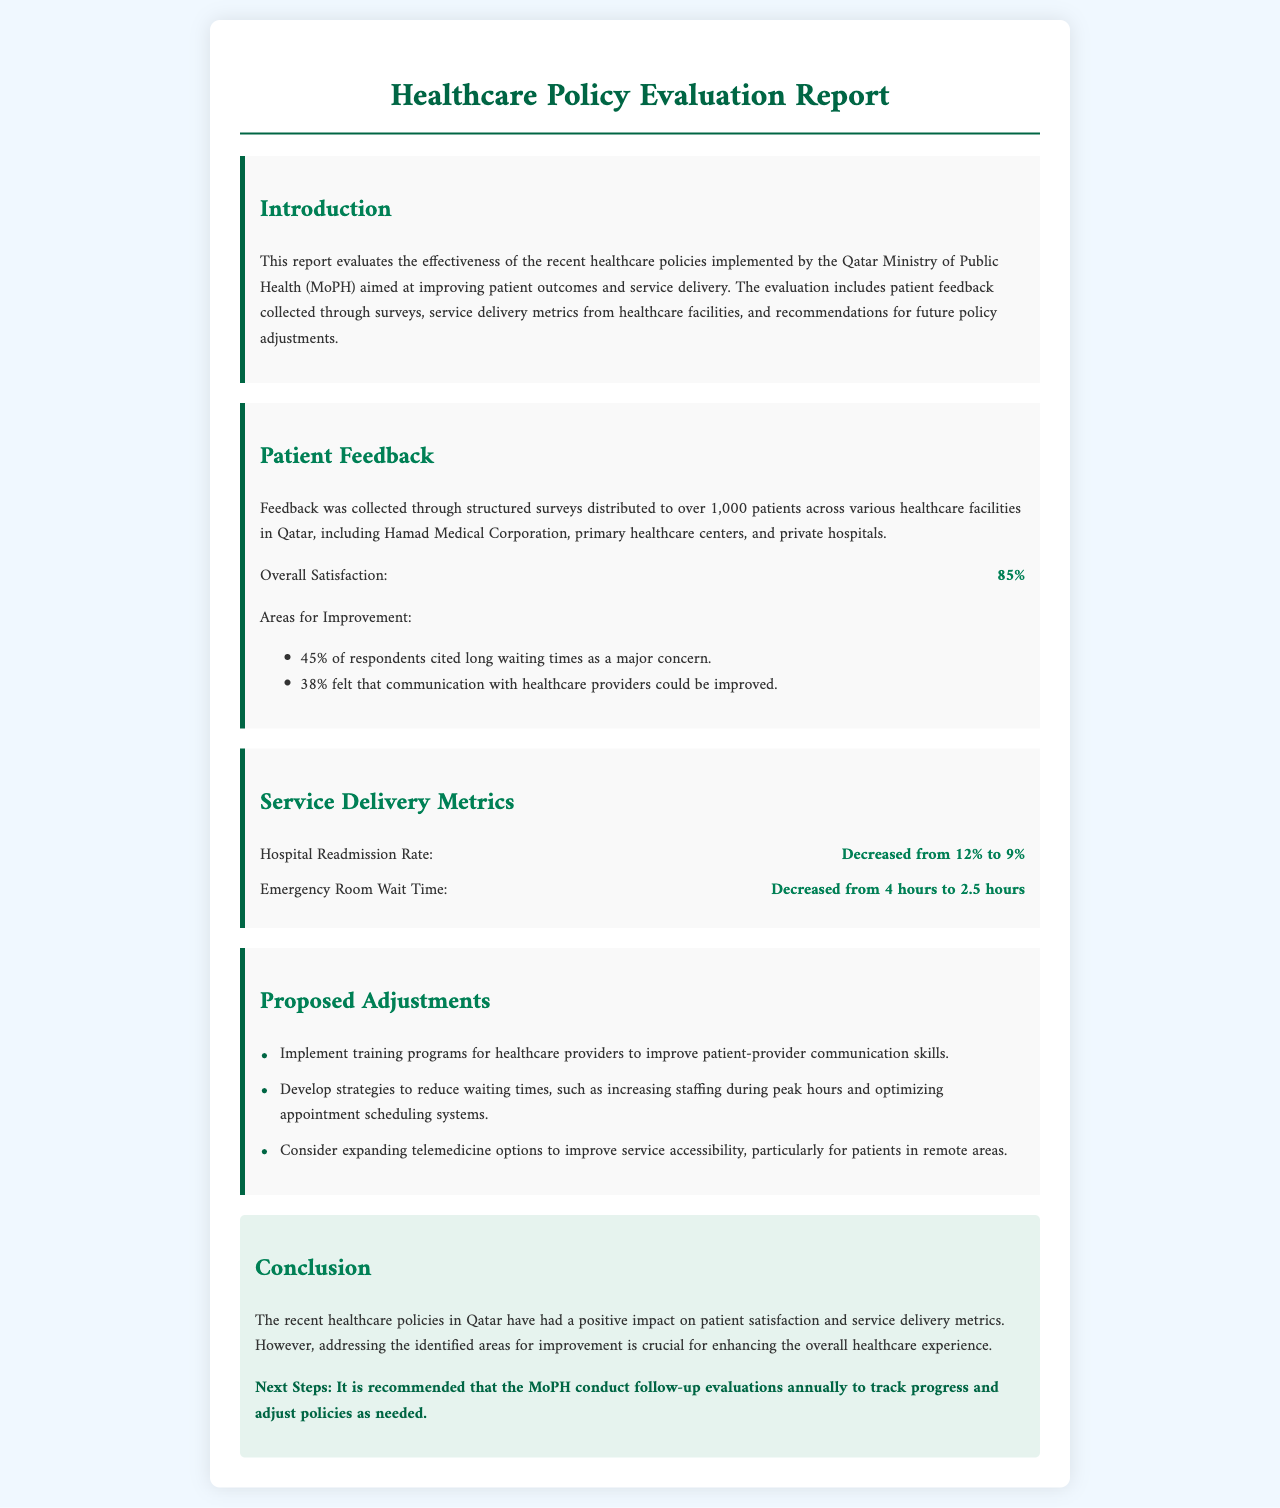What is the overall patient satisfaction percentage? The patient satisfaction percentage provided in the document is 85%.
Answer: 85% What is the hospital readmission rate before the recent policies? The document states that the hospital readmission rate decreased from 12%.
Answer: 12% Which healthcare facilities were involved in the patient feedback survey? The document mentions Hamad Medical Corporation, primary healthcare centers, and private hospitals.
Answer: Hamad Medical Corporation, primary healthcare centers, and private hospitals What percentage of respondents cited long waiting times as a concern? The document indicates that 45% of respondents cited long waiting times.
Answer: 45% What is one proposed adjustment to improve communication with healthcare providers? The document suggests implementing training programs for healthcare providers.
Answer: Implement training programs for healthcare providers What was the emergency room wait time before the implementation of recent policies? The document shows that the emergency room wait time decreased from 4 hours.
Answer: 4 hours How often does the report recommend conducting follow-up evaluations? The document recommends conducting follow-up evaluations annually.
Answer: Annually What was the decrease in emergency room wait time after the recent policies? The document states that the emergency room wait time decreased from 4 hours to 2.5 hours.
Answer: 1.5 hours What color is used for the heading in the conclusion section? The document highlights that the conclusion section uses a background color of light green (e6f3ee).
Answer: Light green 